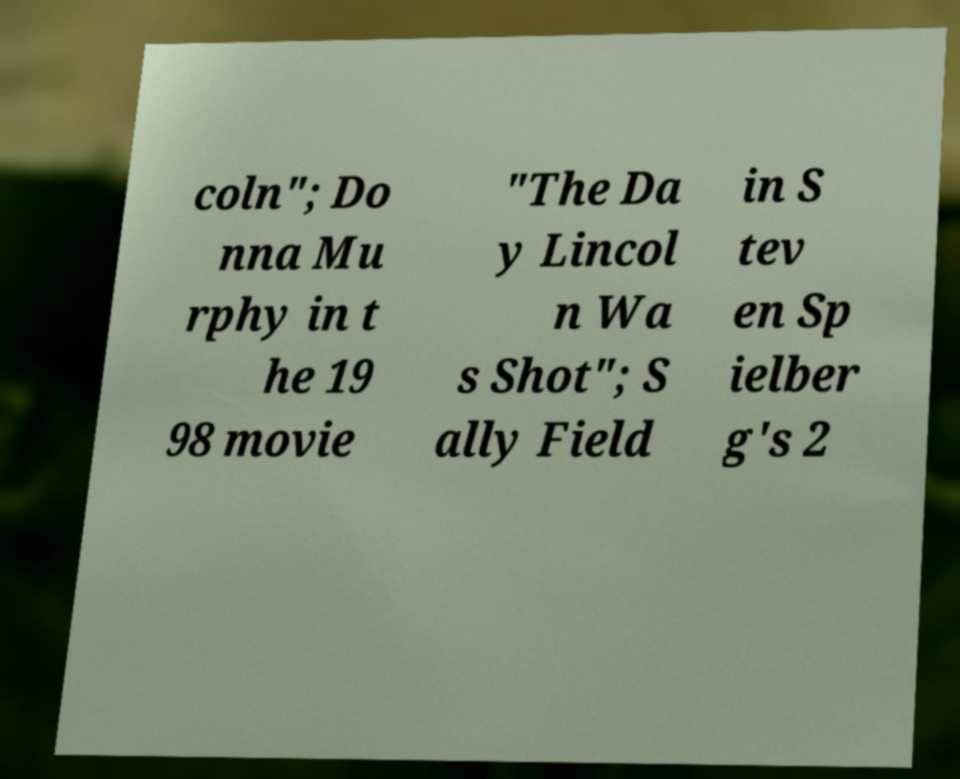Could you extract and type out the text from this image? coln"; Do nna Mu rphy in t he 19 98 movie "The Da y Lincol n Wa s Shot"; S ally Field in S tev en Sp ielber g's 2 